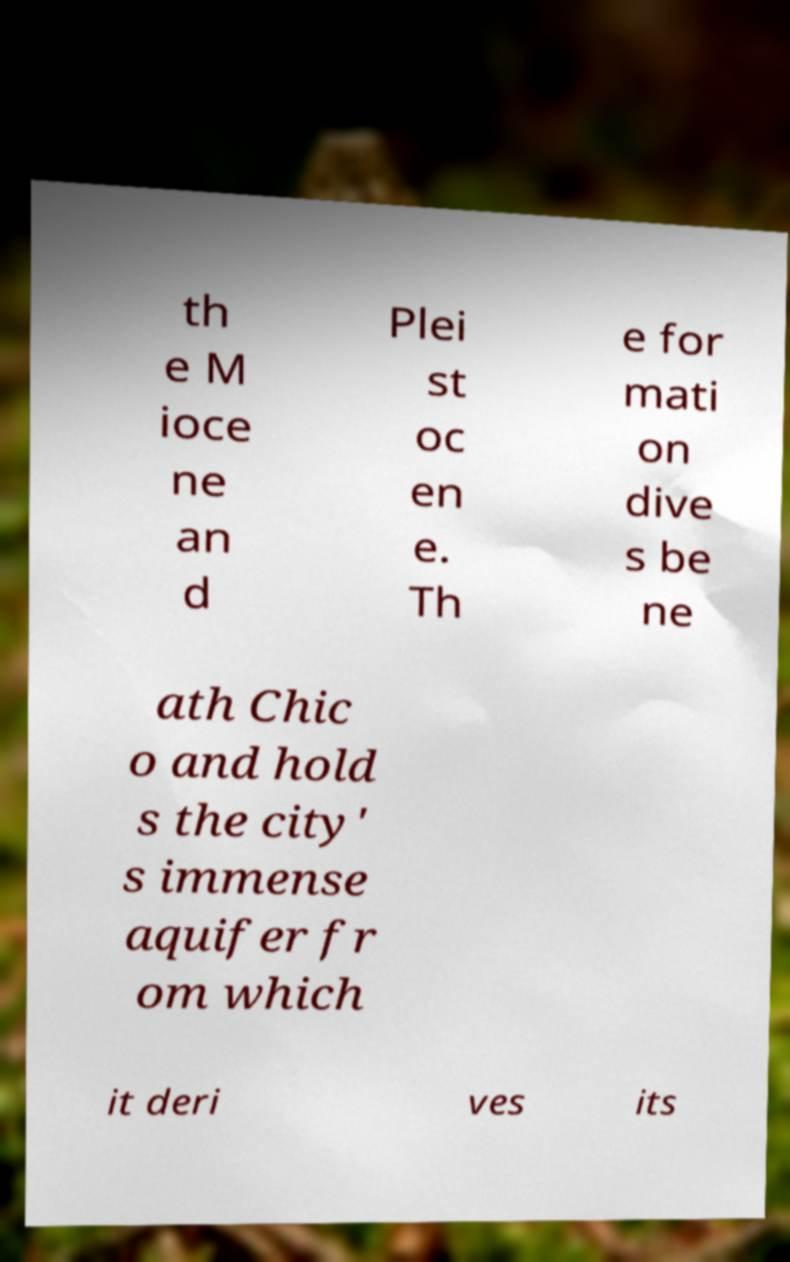Please identify and transcribe the text found in this image. th e M ioce ne an d Plei st oc en e. Th e for mati on dive s be ne ath Chic o and hold s the city' s immense aquifer fr om which it deri ves its 